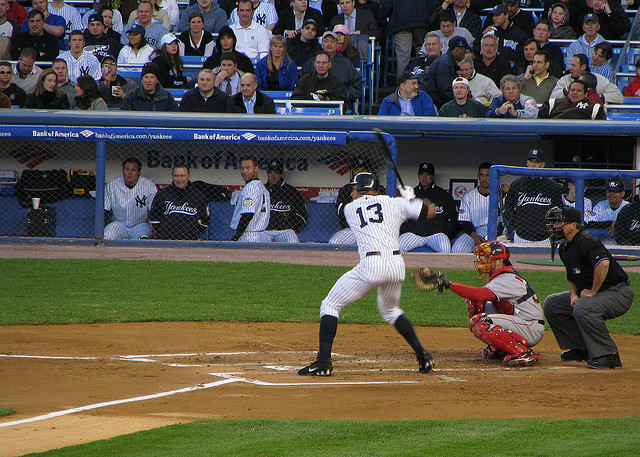Identify the text displayed in this image. Bank of America Bank America Y bankofamerica.com/yankees Yankees M Bank of America 13 